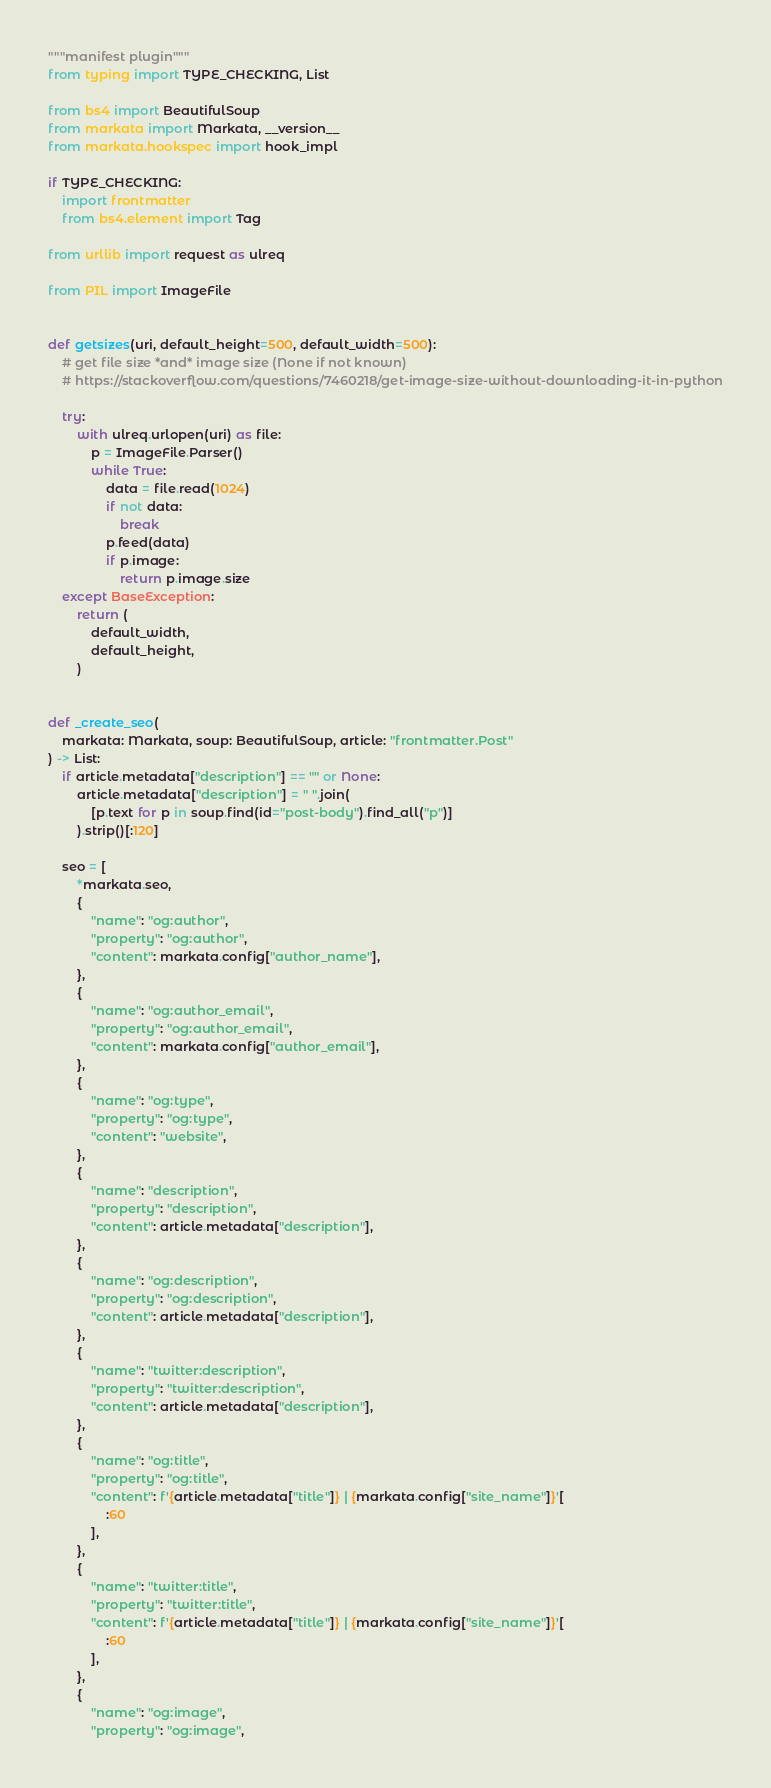Convert code to text. <code><loc_0><loc_0><loc_500><loc_500><_Python_>"""manifest plugin"""
from typing import TYPE_CHECKING, List

from bs4 import BeautifulSoup
from markata import Markata, __version__
from markata.hookspec import hook_impl

if TYPE_CHECKING:
    import frontmatter
    from bs4.element import Tag

from urllib import request as ulreq

from PIL import ImageFile


def getsizes(uri, default_height=500, default_width=500):
    # get file size *and* image size (None if not known)
    # https://stackoverflow.com/questions/7460218/get-image-size-without-downloading-it-in-python

    try:
        with ulreq.urlopen(uri) as file:
            p = ImageFile.Parser()
            while True:
                data = file.read(1024)
                if not data:
                    break
                p.feed(data)
                if p.image:
                    return p.image.size
    except BaseException:
        return (
            default_width,
            default_height,
        )


def _create_seo(
    markata: Markata, soup: BeautifulSoup, article: "frontmatter.Post"
) -> List:
    if article.metadata["description"] == "" or None:
        article.metadata["description"] = " ".join(
            [p.text for p in soup.find(id="post-body").find_all("p")]
        ).strip()[:120]

    seo = [
        *markata.seo,
        {
            "name": "og:author",
            "property": "og:author",
            "content": markata.config["author_name"],
        },
        {
            "name": "og:author_email",
            "property": "og:author_email",
            "content": markata.config["author_email"],
        },
        {
            "name": "og:type",
            "property": "og:type",
            "content": "website",
        },
        {
            "name": "description",
            "property": "description",
            "content": article.metadata["description"],
        },
        {
            "name": "og:description",
            "property": "og:description",
            "content": article.metadata["description"],
        },
        {
            "name": "twitter:description",
            "property": "twitter:description",
            "content": article.metadata["description"],
        },
        {
            "name": "og:title",
            "property": "og:title",
            "content": f'{article.metadata["title"]} | {markata.config["site_name"]}'[
                :60
            ],
        },
        {
            "name": "twitter:title",
            "property": "twitter:title",
            "content": f'{article.metadata["title"]} | {markata.config["site_name"]}'[
                :60
            ],
        },
        {
            "name": "og:image",
            "property": "og:image",</code> 